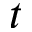<formula> <loc_0><loc_0><loc_500><loc_500>t</formula> 